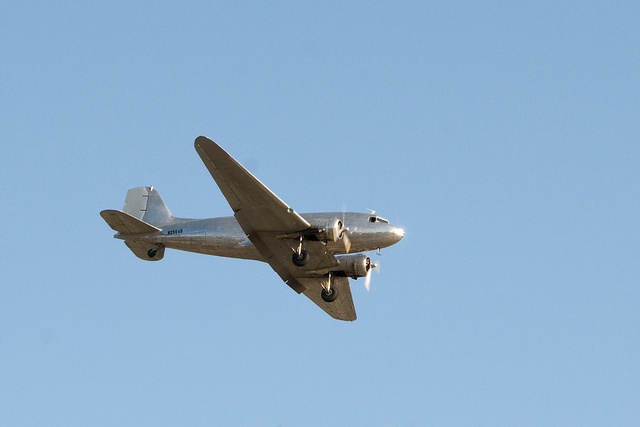Describe the objects in this image and their specific colors. I can see a airplane in lightblue, black, and gray tones in this image. 